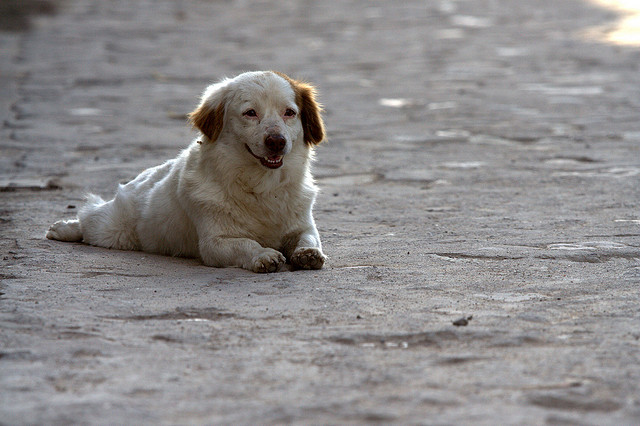<image>What color is the asphalt? I am not sure about the color of the asphalt. It could be gray, brown or black. What color is the asphalt? The color of the asphalt is gray. 